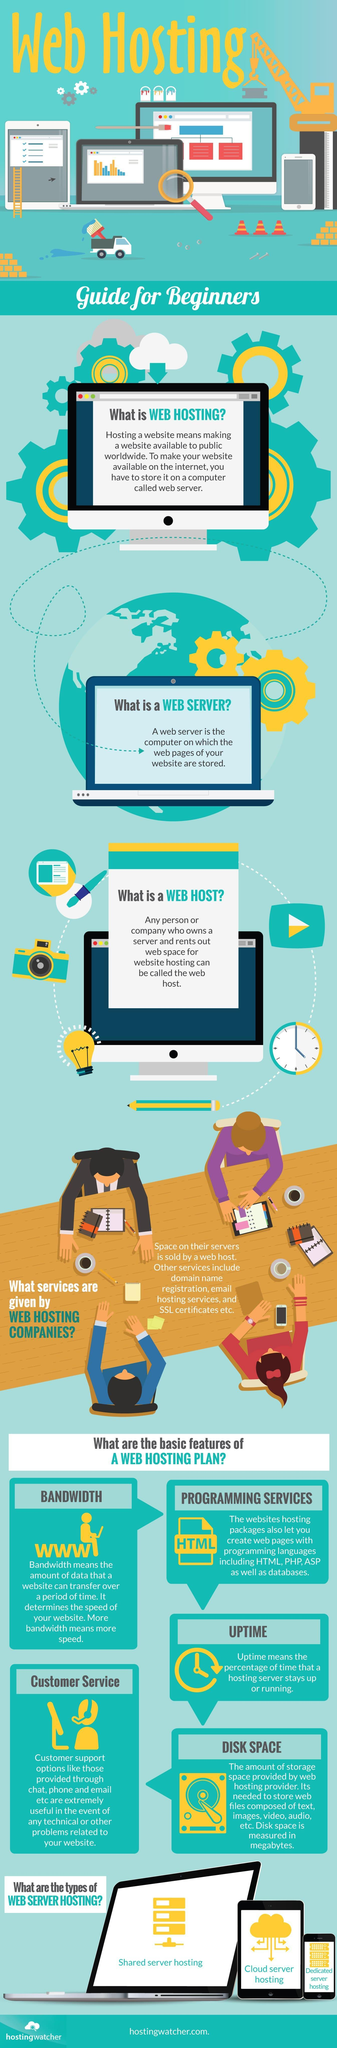Here , which type of web hosting is shown on a tablet screen?
Answer the question with a short phrase. cloud server hosting How many types of server hosting are shown here? 3 